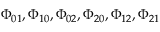Convert formula to latex. <formula><loc_0><loc_0><loc_500><loc_500>\Phi _ { 0 1 } , \Phi _ { 1 0 } , \Phi _ { 0 2 } , \Phi _ { 2 0 } , \Phi _ { 1 2 } , \Phi _ { 2 1 }</formula> 